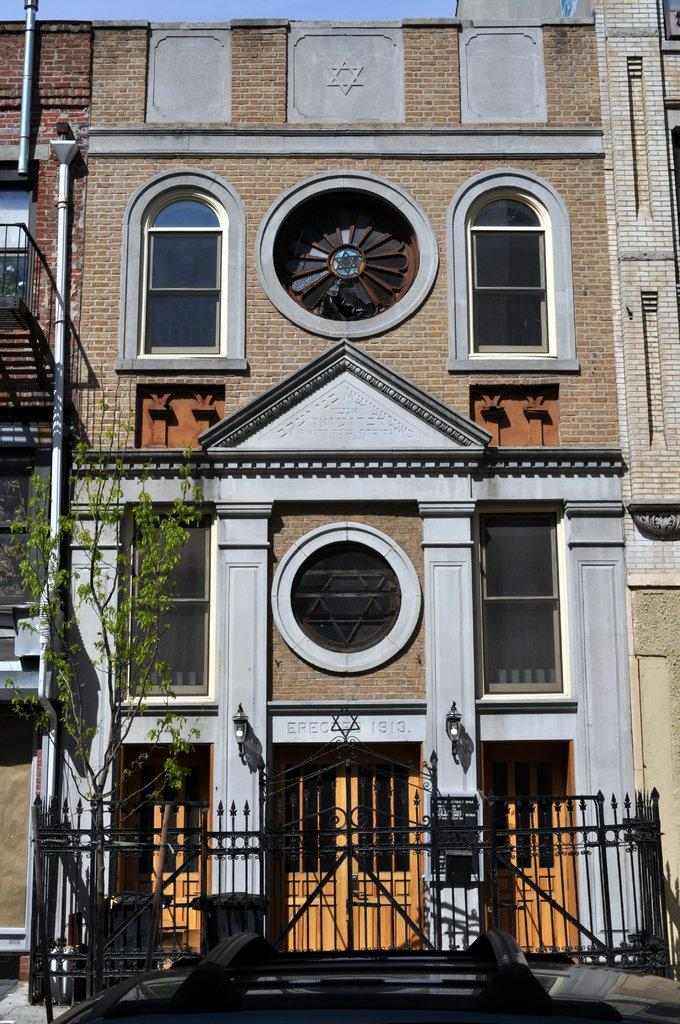What type of vegetation is on the left side of the image? There is a tree on the left side of the image. What is located at the bottom of the image? There is an iron fencing at the bottom of the image. What type of building is in the middle of the image? There is a big building with glass windows in the middle of the image. What is the texture of the bean in the image? There is no bean present in the image. What time of day is depicted in the image? The time of day cannot be determined from the image, as there are no specific clues or indicators present. 